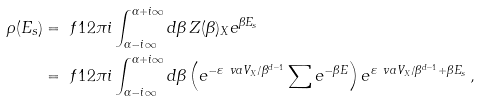Convert formula to latex. <formula><loc_0><loc_0><loc_500><loc_500>\rho ( E _ { s } ) & = \ f { 1 } { 2 \pi i } \int _ { \alpha - i \infty } ^ { \alpha + i \infty } d \beta \, Z ( \beta ) _ { X } e ^ { \beta E _ { s } } \\ & = \ f { 1 } { 2 \pi i } \int _ { \alpha - i \infty } ^ { \alpha + i \infty } d \beta \left ( e ^ { - \varepsilon _ { \ } v a V _ { X } / \beta ^ { d - 1 } } \sum e ^ { - \beta E } \right ) e ^ { \varepsilon _ { \ } v a V _ { X } / \beta ^ { d - 1 } + \beta E _ { s } } \, ,</formula> 